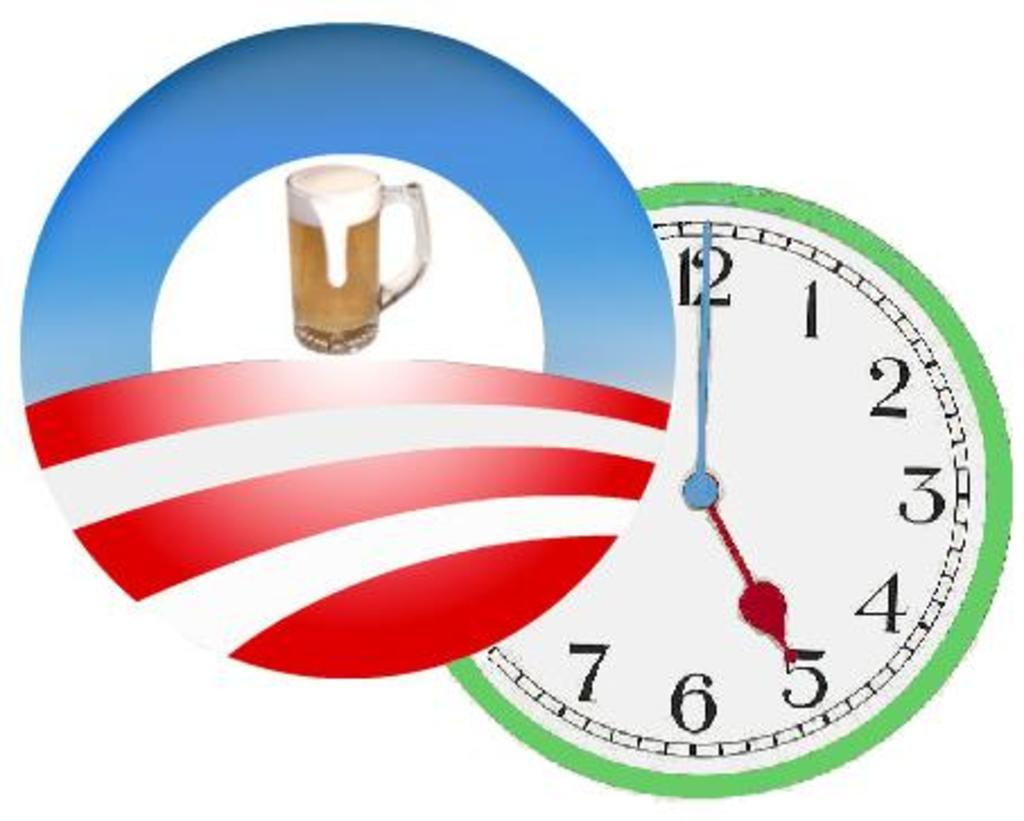<image>
Create a compact narrative representing the image presented. A clock with a green rim, that is reading 5:00pm 